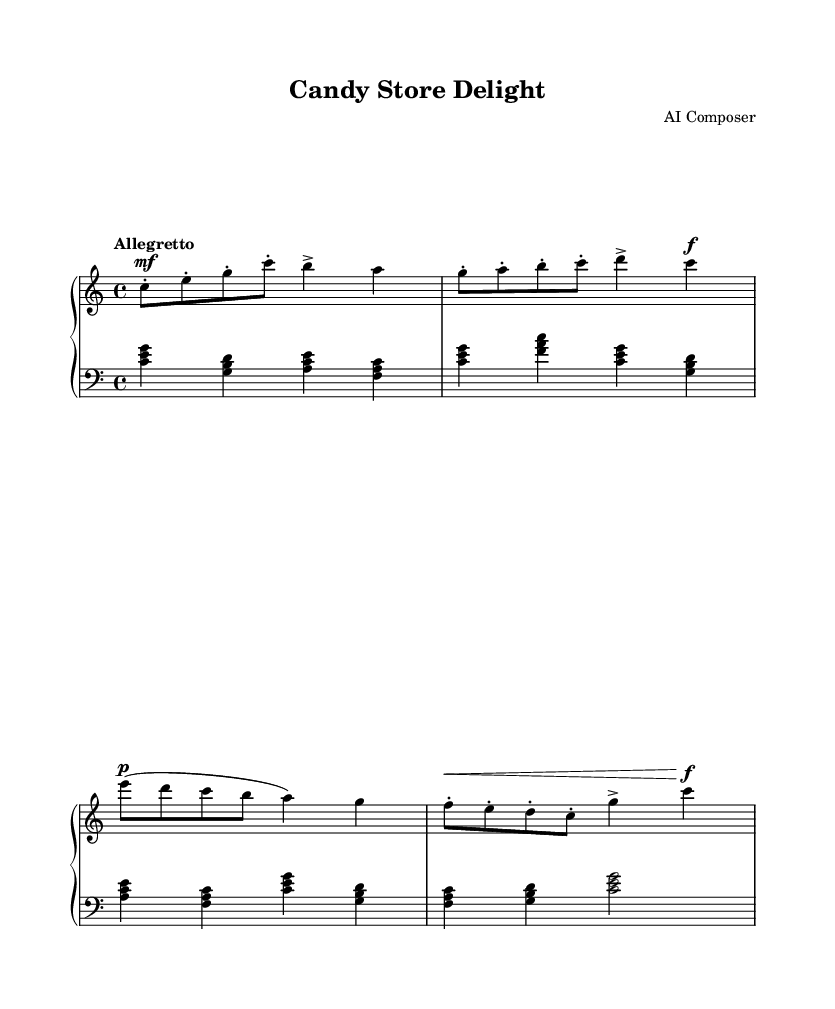What is the key signature of this music? The key signature is C major, which can be identified by the absence of any sharps or flats in the sheet music. Look for the key signature placed at the beginning of the staff, which in this case indicates that the scale starts and centers around the note C.
Answer: C major What is the time signature of this piece? The time signature is 4/4, indicated by the numbers at the beginning of the staff. This means there are four beats per measure, and each beat is represented by a quarter note.
Answer: 4/4 What is the tempo marking of the composition? The tempo marking is "Allegretto," which can be found above the staff. This term gives an indication of the speed at which the piece should be played, specifically indicating a moderately fast tempo.
Answer: Allegretto How many measures are in the sheet music? By counting the divisions in the music sheet, there are 8 measures present. Each measure is separated by vertical lines, making them distinct.
Answer: 8 What dynamic marking is used for the right hand at the beginning? The dynamic marking is "mf," meaning mezzo-forte. This indicates that the right hand should play moderately loud right from the start of the piece. The marking can be found just above the first note in the right-hand part.
Answer: mf How does the left hand initially contribute to the harmony? The left hand plays chords consisting of the root, third, and fifth notes of each chord. For example, the first measure contains a chord built from the notes C, E, and G, which creates a C major triad, providing a harmonic foundation for the right-hand melody.
Answer: Chords What character or mood does this piece evoke? This piece evokes a playful and joyful mood, particularly suited to the theme of a child's excitement when visiting a candy store. The lively tempo, along with the melodic and harmonic choices, create a sparkling and whimsical atmosphere reminiscent of sweetness and delight.
Answer: Playful 